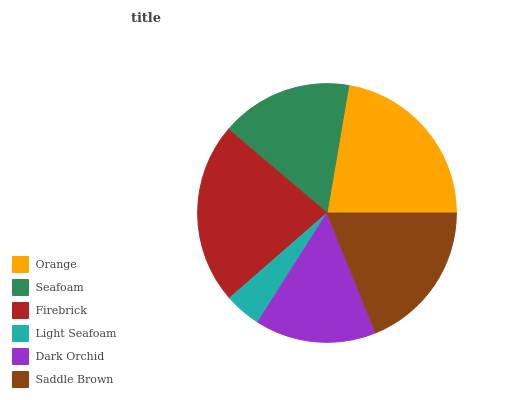Is Light Seafoam the minimum?
Answer yes or no. Yes. Is Firebrick the maximum?
Answer yes or no. Yes. Is Seafoam the minimum?
Answer yes or no. No. Is Seafoam the maximum?
Answer yes or no. No. Is Orange greater than Seafoam?
Answer yes or no. Yes. Is Seafoam less than Orange?
Answer yes or no. Yes. Is Seafoam greater than Orange?
Answer yes or no. No. Is Orange less than Seafoam?
Answer yes or no. No. Is Saddle Brown the high median?
Answer yes or no. Yes. Is Seafoam the low median?
Answer yes or no. Yes. Is Firebrick the high median?
Answer yes or no. No. Is Saddle Brown the low median?
Answer yes or no. No. 